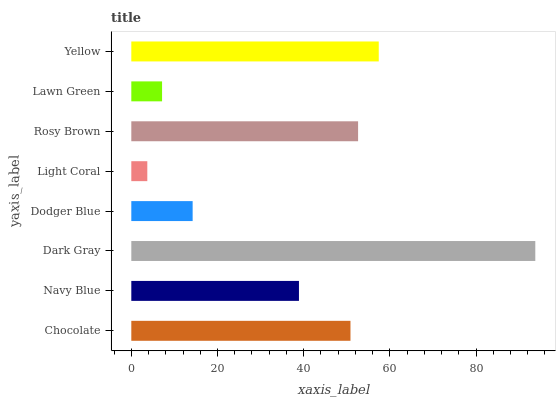Is Light Coral the minimum?
Answer yes or no. Yes. Is Dark Gray the maximum?
Answer yes or no. Yes. Is Navy Blue the minimum?
Answer yes or no. No. Is Navy Blue the maximum?
Answer yes or no. No. Is Chocolate greater than Navy Blue?
Answer yes or no. Yes. Is Navy Blue less than Chocolate?
Answer yes or no. Yes. Is Navy Blue greater than Chocolate?
Answer yes or no. No. Is Chocolate less than Navy Blue?
Answer yes or no. No. Is Chocolate the high median?
Answer yes or no. Yes. Is Navy Blue the low median?
Answer yes or no. Yes. Is Dark Gray the high median?
Answer yes or no. No. Is Dodger Blue the low median?
Answer yes or no. No. 